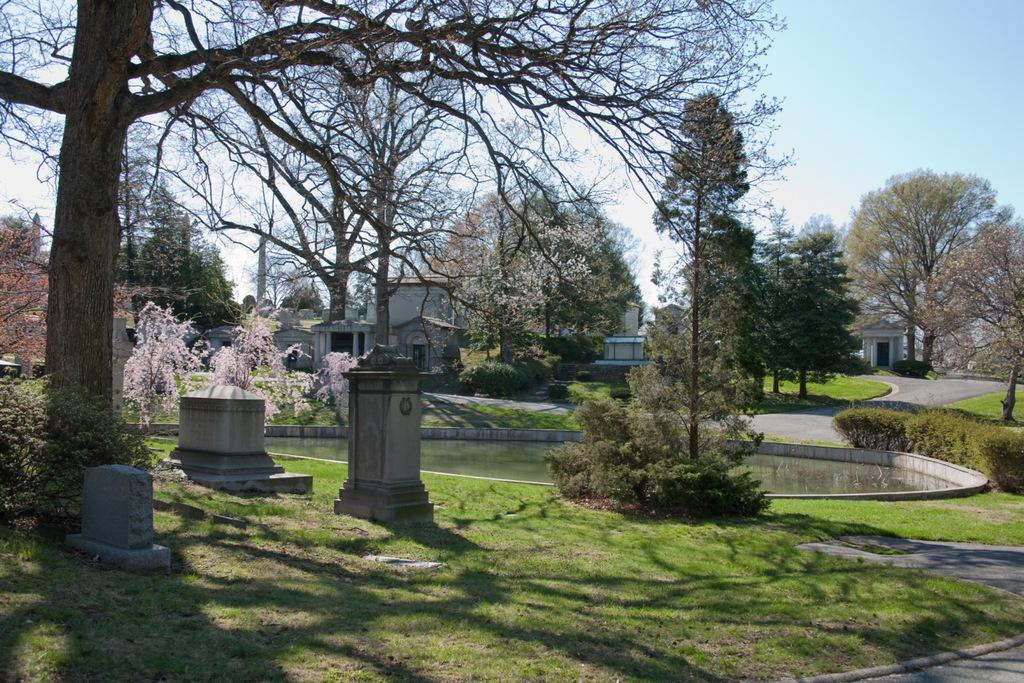What type of vegetation can be seen in the image? There are trees in the image. What other natural elements are present in the image? There are stones and grass visible in the image. Can you describe the lighting in the image? There are shadows in the image, which suggests that there is a light source casting these shadows. What can be seen in the background of the image? There are buildings and the sky visible in the background of the image. How loud is the quiet in the image? The concept of "quiet" is not something that can be measured or observed in an image, as it refers to the absence of sound. What type of ball is being used to play a game in the image? There is no ball present in the image. 